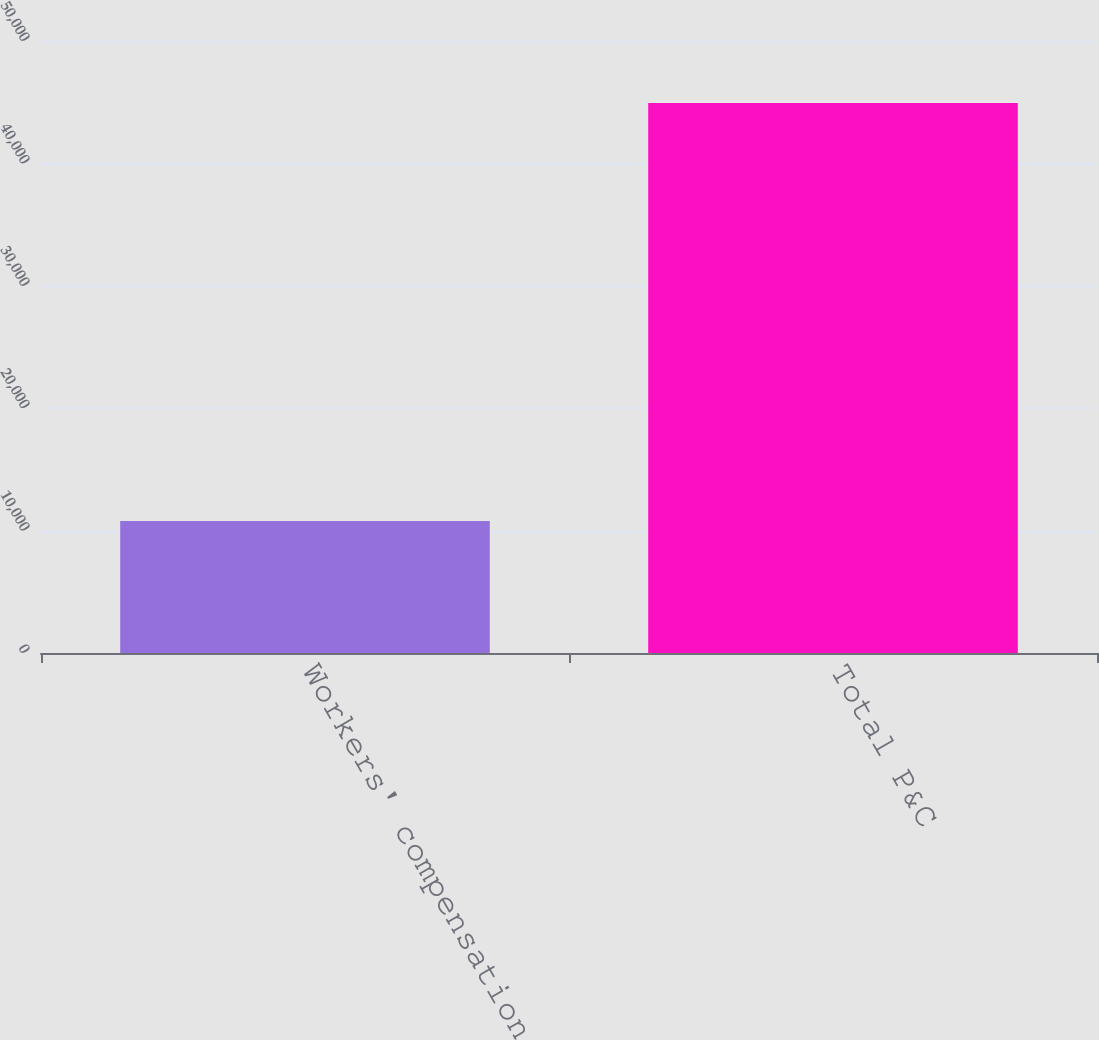<chart> <loc_0><loc_0><loc_500><loc_500><bar_chart><fcel>Workers' compensation<fcel>Total P&C<nl><fcel>10775<fcel>44925<nl></chart> 